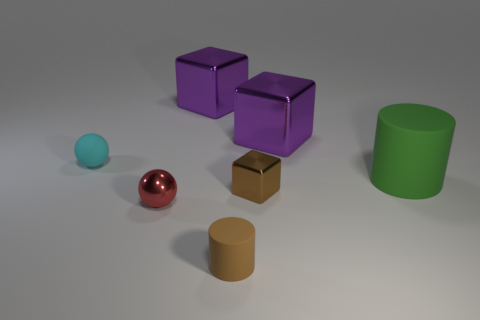There is a rubber thing that is the same color as the small metallic cube; what is its size?
Ensure brevity in your answer.  Small. Is there a brown thing that has the same material as the cyan thing?
Your answer should be very brief. Yes. The small cyan object is what shape?
Give a very brief answer. Sphere. There is a small rubber thing that is on the right side of the sphere behind the green thing; what shape is it?
Keep it short and to the point. Cylinder. What number of other objects are the same shape as the green object?
Make the answer very short. 1. What is the size of the shiny cube that is in front of the big purple metal cube that is right of the tiny brown metallic object?
Make the answer very short. Small. Are there any large blue matte cylinders?
Give a very brief answer. No. How many green matte things are in front of the small sphere in front of the matte sphere?
Your response must be concise. 0. There is a matte object that is in front of the green matte cylinder; what is its shape?
Offer a very short reply. Cylinder. What material is the block that is in front of the big purple block that is to the right of the brown object that is in front of the red shiny ball?
Your answer should be very brief. Metal. 